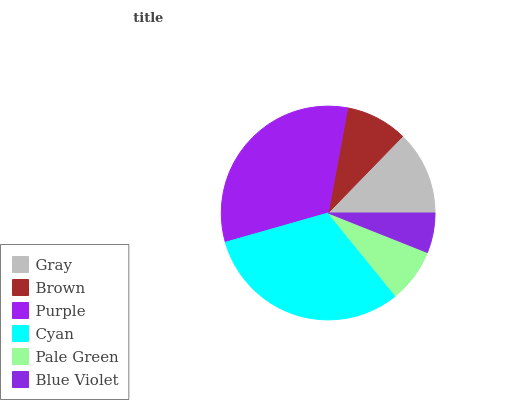Is Blue Violet the minimum?
Answer yes or no. Yes. Is Purple the maximum?
Answer yes or no. Yes. Is Brown the minimum?
Answer yes or no. No. Is Brown the maximum?
Answer yes or no. No. Is Gray greater than Brown?
Answer yes or no. Yes. Is Brown less than Gray?
Answer yes or no. Yes. Is Brown greater than Gray?
Answer yes or no. No. Is Gray less than Brown?
Answer yes or no. No. Is Gray the high median?
Answer yes or no. Yes. Is Brown the low median?
Answer yes or no. Yes. Is Purple the high median?
Answer yes or no. No. Is Cyan the low median?
Answer yes or no. No. 